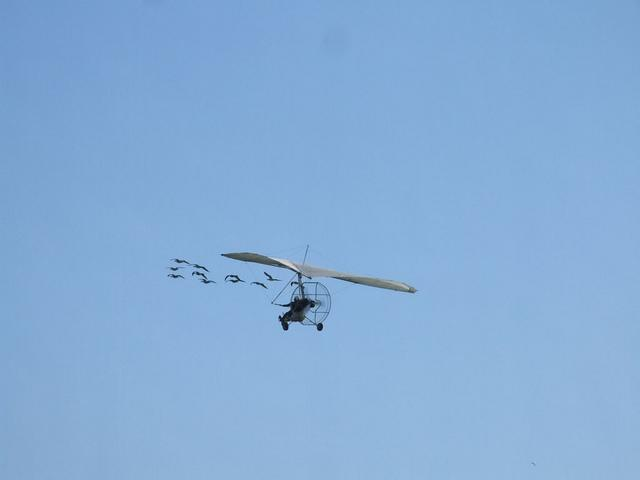Which object is/are in the greatest threat? Please explain your reasoning. birds. The birds could get in the way. 